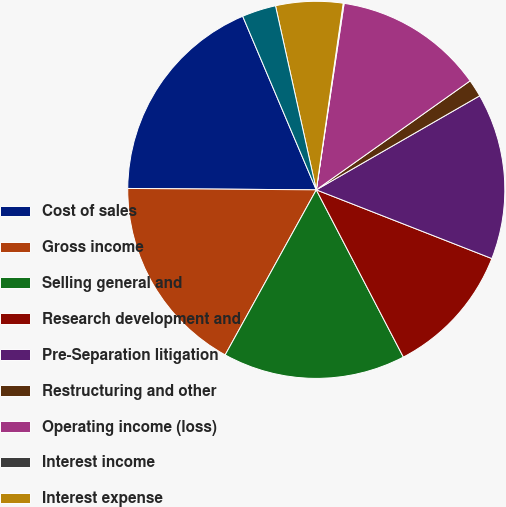Convert chart. <chart><loc_0><loc_0><loc_500><loc_500><pie_chart><fcel>Cost of sales<fcel>Gross income<fcel>Selling general and<fcel>Research development and<fcel>Pre-Separation litigation<fcel>Restructuring and other<fcel>Operating income (loss)<fcel>Interest income<fcel>Interest expense<fcel>Other income (expense) net<nl><fcel>18.5%<fcel>17.09%<fcel>15.67%<fcel>11.42%<fcel>14.25%<fcel>1.5%<fcel>12.83%<fcel>0.08%<fcel>5.75%<fcel>2.91%<nl></chart> 